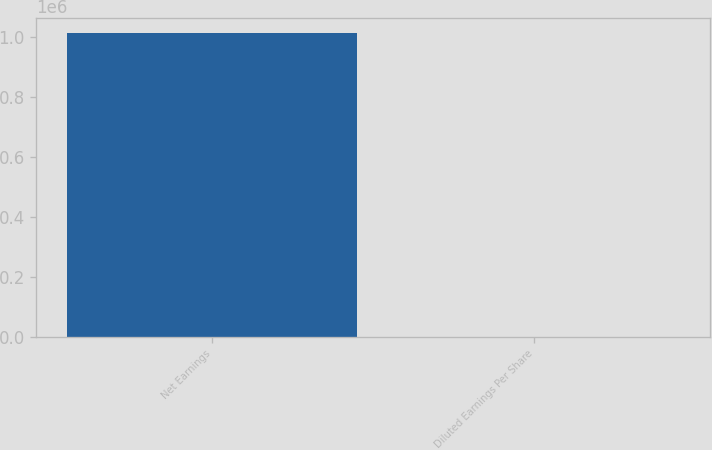<chart> <loc_0><loc_0><loc_500><loc_500><bar_chart><fcel>Net Earnings<fcel>Diluted Earnings Per Share<nl><fcel>1.01214e+06<fcel>1.86<nl></chart> 